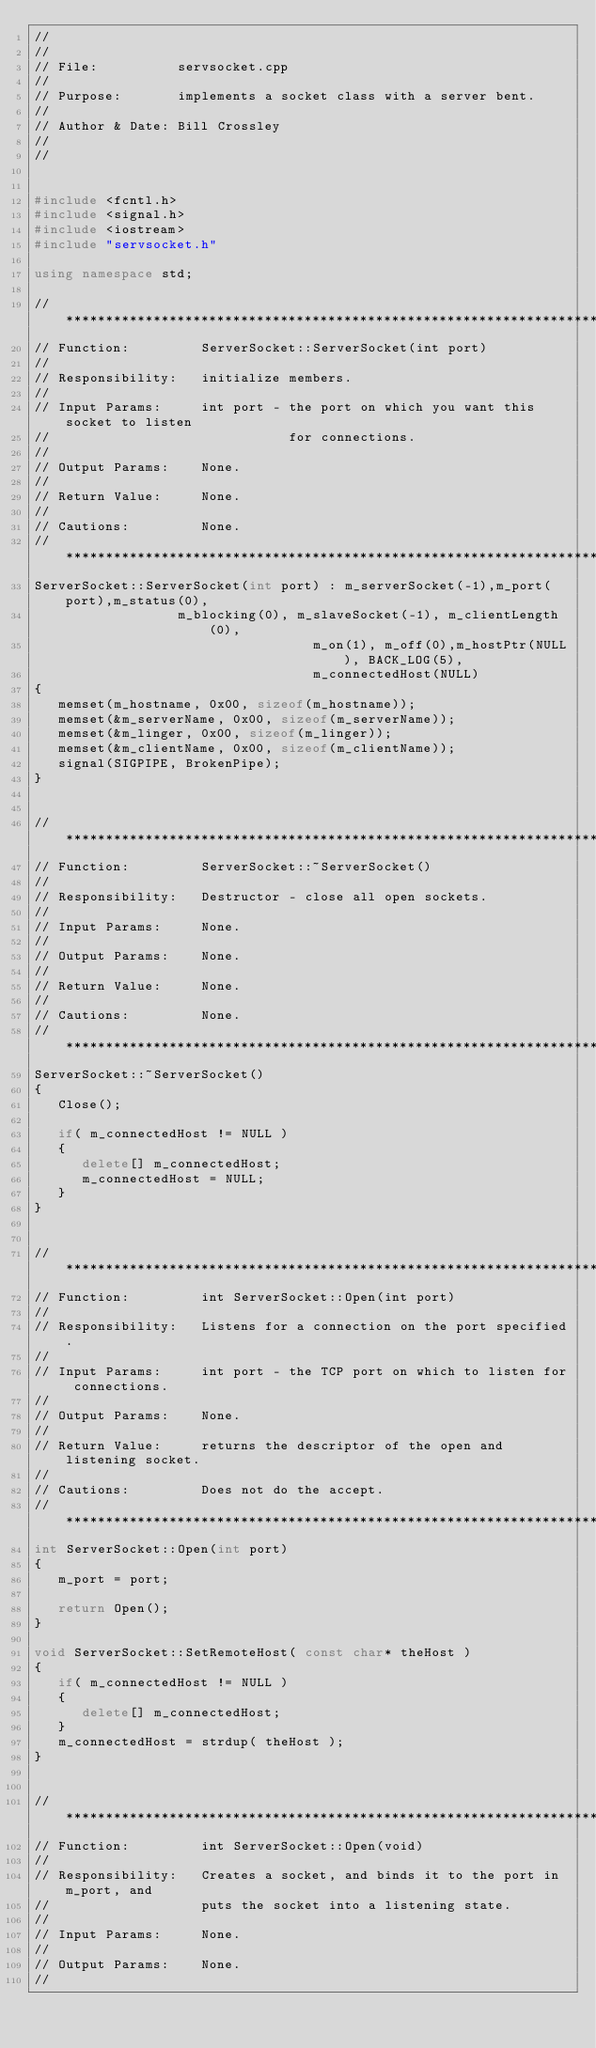Convert code to text. <code><loc_0><loc_0><loc_500><loc_500><_C++_>//
//
// File:          servsocket.cpp
//
// Purpose:       implements a socket class with a server bent.
//
// Author & Date: Bill Crossley
//
//


#include <fcntl.h>
#include <signal.h>
#include <iostream>
#include "servsocket.h"

using namespace std;

//*****************************************************************************
// Function:         ServerSocket::ServerSocket(int port)
//
// Responsibility:   initialize members.
//
// Input Params:     int port - the port on which you want this socket to listen
//                              for connections.
//
// Output Params:    None.
//
// Return Value:     None.
//
// Cautions:         None.
//*****************************************************************************
ServerSocket::ServerSocket(int port) : m_serverSocket(-1),m_port(port),m_status(0),
									m_blocking(0), m_slaveSocket(-1), m_clientLength(0),
                                   m_on(1), m_off(0),m_hostPtr(NULL), BACK_LOG(5),
                                   m_connectedHost(NULL)
{
   memset(m_hostname, 0x00, sizeof(m_hostname));
   memset(&m_serverName, 0x00, sizeof(m_serverName));
   memset(&m_linger, 0x00, sizeof(m_linger));
   memset(&m_clientName, 0x00, sizeof(m_clientName));
   signal(SIGPIPE, BrokenPipe);
}


//*****************************************************************************
// Function:         ServerSocket::~ServerSocket()
//
// Responsibility:   Destructor - close all open sockets.
//
// Input Params:     None.
//
// Output Params:    None.
//
// Return Value:     None.
//
// Cautions:         None.
//****************************************************************************
ServerSocket::~ServerSocket()
{
   Close();

   if( m_connectedHost != NULL )
   {
      delete[] m_connectedHost;
      m_connectedHost = NULL;
   }
}


//*****************************************************************************
// Function:         int ServerSocket::Open(int port)
//
// Responsibility:   Listens for a connection on the port specified.
//
// Input Params:     int port - the TCP port on which to listen for connections.
//
// Output Params:    None.
//
// Return Value:     returns the descriptor of the open and listening socket.
//
// Cautions:         Does not do the accept.
//****************************************************************************
int ServerSocket::Open(int port)
{
   m_port = port;

   return Open();
}

void ServerSocket::SetRemoteHost( const char* theHost )
{
   if( m_connectedHost != NULL )
   {
      delete[] m_connectedHost;
   }
   m_connectedHost = strdup( theHost );
}


//*****************************************************************************
// Function:         int ServerSocket::Open(void)
//
// Responsibility:   Creates a socket, and binds it to the port in m_port, and
//                   puts the socket into a listening state.
//
// Input Params:     None.
//
// Output Params:    None.
//</code> 